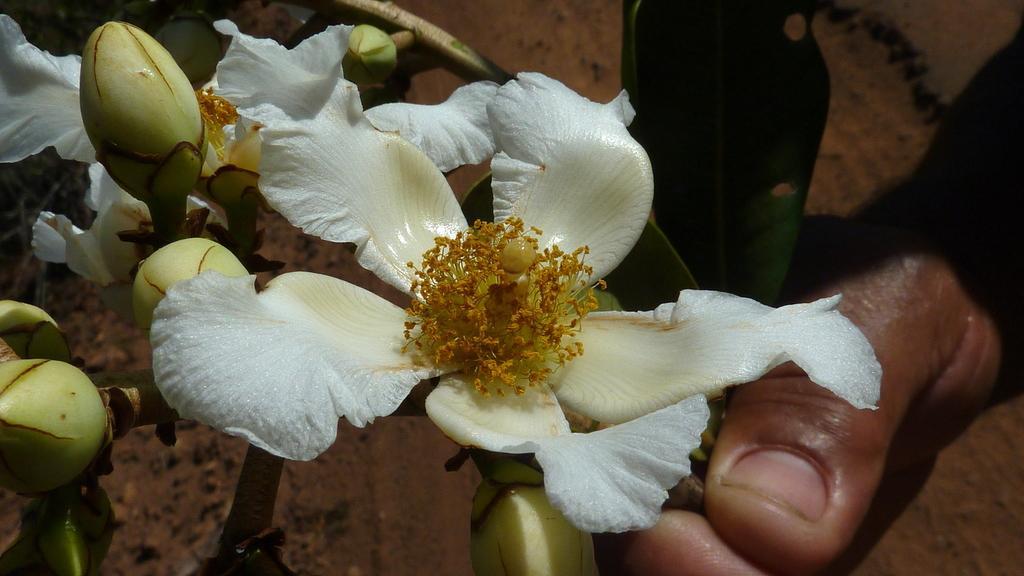How would you summarize this image in a sentence or two? In the foreground of the picture there are flowers, buds, stem and a person´s hand. In the background it is looking like floor and there are leaves also. 